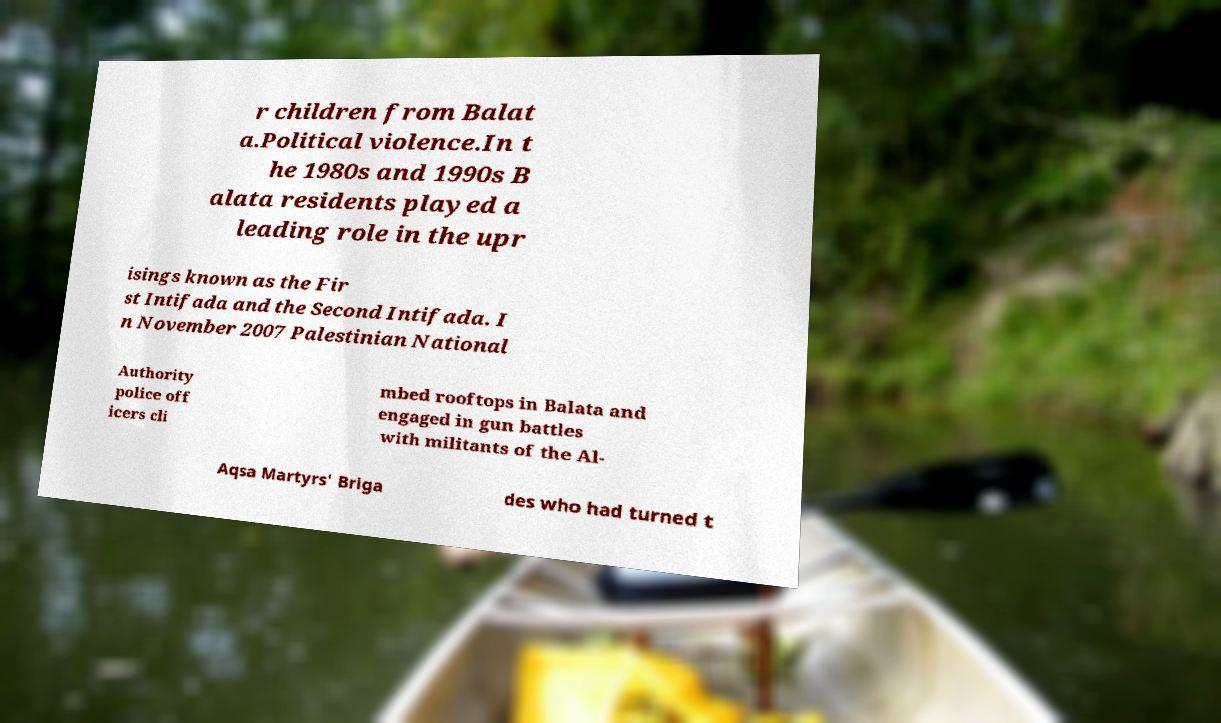Could you assist in decoding the text presented in this image and type it out clearly? r children from Balat a.Political violence.In t he 1980s and 1990s B alata residents played a leading role in the upr isings known as the Fir st Intifada and the Second Intifada. I n November 2007 Palestinian National Authority police off icers cli mbed rooftops in Balata and engaged in gun battles with militants of the Al- Aqsa Martyrs' Briga des who had turned t 